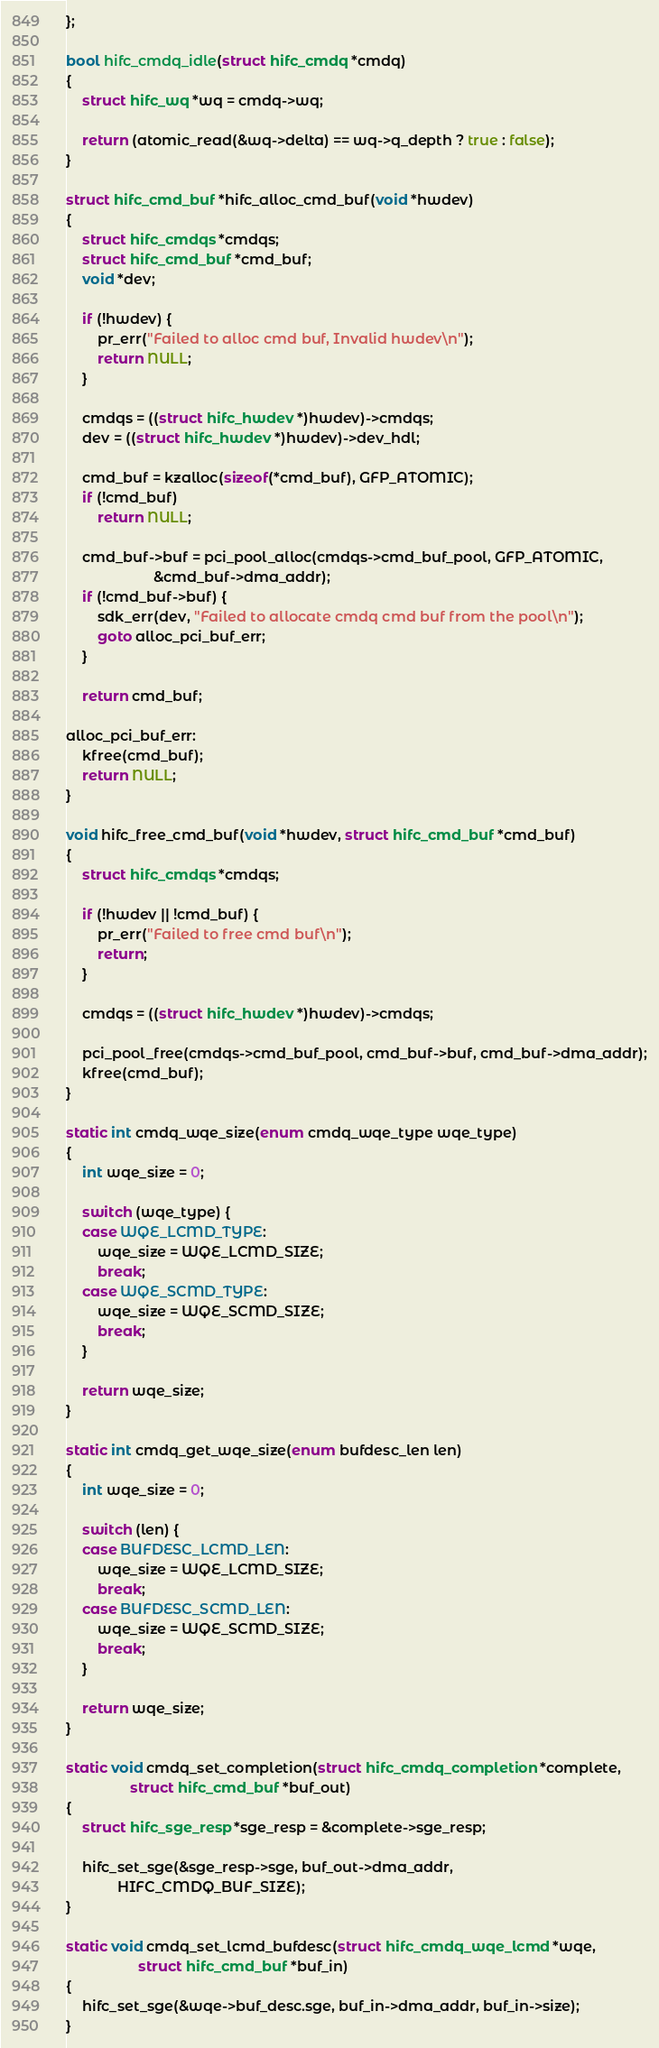<code> <loc_0><loc_0><loc_500><loc_500><_C_>};

bool hifc_cmdq_idle(struct hifc_cmdq *cmdq)
{
	struct hifc_wq *wq = cmdq->wq;

	return (atomic_read(&wq->delta) == wq->q_depth ? true : false);
}

struct hifc_cmd_buf *hifc_alloc_cmd_buf(void *hwdev)
{
	struct hifc_cmdqs *cmdqs;
	struct hifc_cmd_buf *cmd_buf;
	void *dev;

	if (!hwdev) {
		pr_err("Failed to alloc cmd buf, Invalid hwdev\n");
		return NULL;
	}

	cmdqs = ((struct hifc_hwdev *)hwdev)->cmdqs;
	dev = ((struct hifc_hwdev *)hwdev)->dev_hdl;

	cmd_buf = kzalloc(sizeof(*cmd_buf), GFP_ATOMIC);
	if (!cmd_buf)
		return NULL;

	cmd_buf->buf = pci_pool_alloc(cmdqs->cmd_buf_pool, GFP_ATOMIC,
				      &cmd_buf->dma_addr);
	if (!cmd_buf->buf) {
		sdk_err(dev, "Failed to allocate cmdq cmd buf from the pool\n");
		goto alloc_pci_buf_err;
	}

	return cmd_buf;

alloc_pci_buf_err:
	kfree(cmd_buf);
	return NULL;
}

void hifc_free_cmd_buf(void *hwdev, struct hifc_cmd_buf *cmd_buf)
{
	struct hifc_cmdqs *cmdqs;

	if (!hwdev || !cmd_buf) {
		pr_err("Failed to free cmd buf\n");
		return;
	}

	cmdqs = ((struct hifc_hwdev *)hwdev)->cmdqs;

	pci_pool_free(cmdqs->cmd_buf_pool, cmd_buf->buf, cmd_buf->dma_addr);
	kfree(cmd_buf);
}

static int cmdq_wqe_size(enum cmdq_wqe_type wqe_type)
{
	int wqe_size = 0;

	switch (wqe_type) {
	case WQE_LCMD_TYPE:
		wqe_size = WQE_LCMD_SIZE;
		break;
	case WQE_SCMD_TYPE:
		wqe_size = WQE_SCMD_SIZE;
		break;
	}

	return wqe_size;
}

static int cmdq_get_wqe_size(enum bufdesc_len len)
{
	int wqe_size = 0;

	switch (len) {
	case BUFDESC_LCMD_LEN:
		wqe_size = WQE_LCMD_SIZE;
		break;
	case BUFDESC_SCMD_LEN:
		wqe_size = WQE_SCMD_SIZE;
		break;
	}

	return wqe_size;
}

static void cmdq_set_completion(struct hifc_cmdq_completion *complete,
				struct hifc_cmd_buf *buf_out)
{
	struct hifc_sge_resp *sge_resp = &complete->sge_resp;

	hifc_set_sge(&sge_resp->sge, buf_out->dma_addr,
		     HIFC_CMDQ_BUF_SIZE);
}

static void cmdq_set_lcmd_bufdesc(struct hifc_cmdq_wqe_lcmd *wqe,
				  struct hifc_cmd_buf *buf_in)
{
	hifc_set_sge(&wqe->buf_desc.sge, buf_in->dma_addr, buf_in->size);
}
</code> 